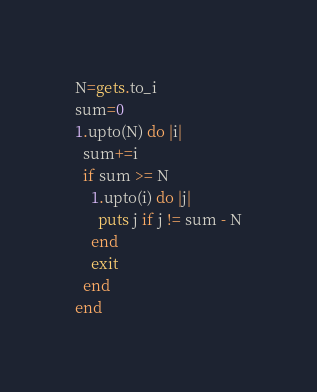Convert code to text. <code><loc_0><loc_0><loc_500><loc_500><_Ruby_>N=gets.to_i
sum=0
1.upto(N) do |i|
  sum+=i
  if sum >= N
    1.upto(i) do |j|
      puts j if j != sum - N
    end
    exit
  end
end</code> 